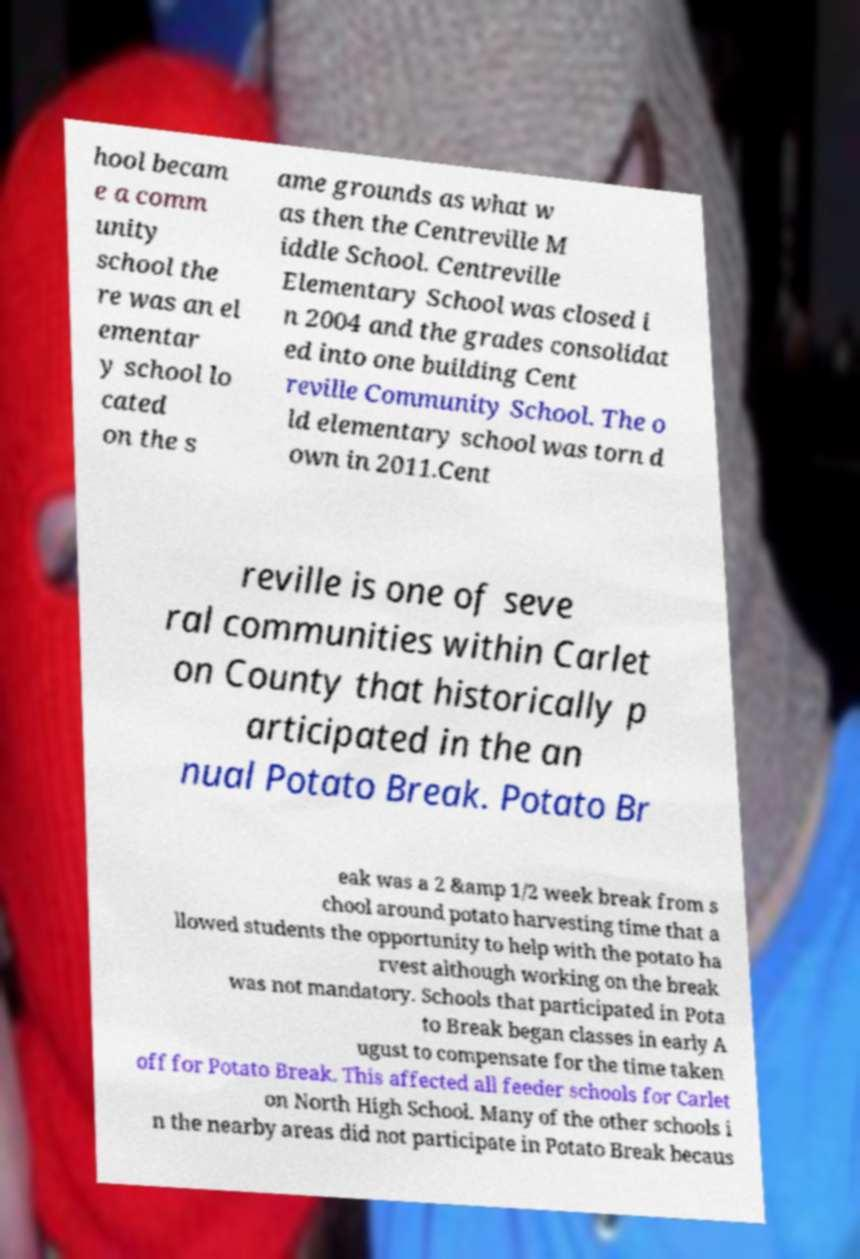I need the written content from this picture converted into text. Can you do that? hool becam e a comm unity school the re was an el ementar y school lo cated on the s ame grounds as what w as then the Centreville M iddle School. Centreville Elementary School was closed i n 2004 and the grades consolidat ed into one building Cent reville Community School. The o ld elementary school was torn d own in 2011.Cent reville is one of seve ral communities within Carlet on County that historically p articipated in the an nual Potato Break. Potato Br eak was a 2 &amp 1/2 week break from s chool around potato harvesting time that a llowed students the opportunity to help with the potato ha rvest although working on the break was not mandatory. Schools that participated in Pota to Break began classes in early A ugust to compensate for the time taken off for Potato Break. This affected all feeder schools for Carlet on North High School. Many of the other schools i n the nearby areas did not participate in Potato Break becaus 